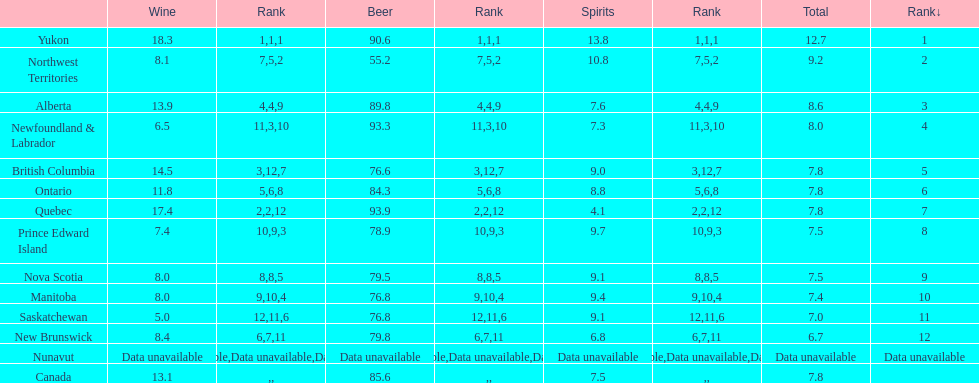Tell me province that drank more than 15 liters of wine. Yukon, Quebec. 